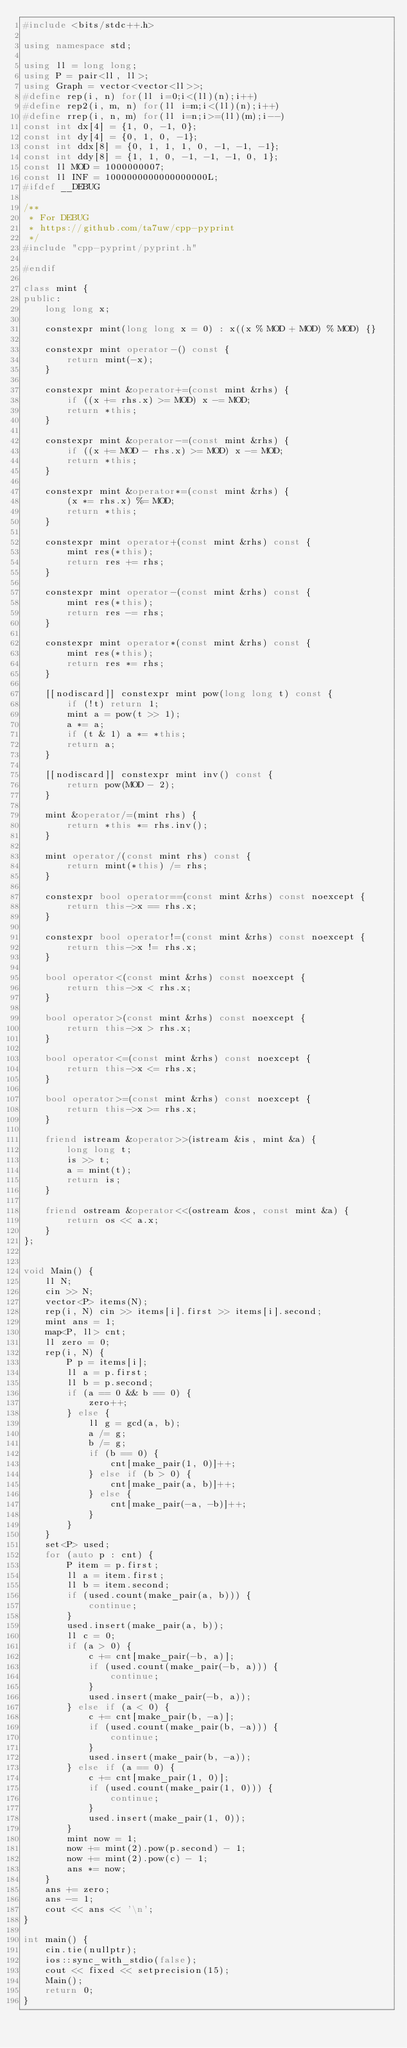<code> <loc_0><loc_0><loc_500><loc_500><_C++_>#include <bits/stdc++.h>

using namespace std;

using ll = long long;
using P = pair<ll, ll>;
using Graph = vector<vector<ll>>;
#define rep(i, n) for(ll i=0;i<(ll)(n);i++)
#define rep2(i, m, n) for(ll i=m;i<(ll)(n);i++)
#define rrep(i, n, m) for(ll i=n;i>=(ll)(m);i--)
const int dx[4] = {1, 0, -1, 0};
const int dy[4] = {0, 1, 0, -1};
const int ddx[8] = {0, 1, 1, 1, 0, -1, -1, -1};
const int ddy[8] = {1, 1, 0, -1, -1, -1, 0, 1};
const ll MOD = 1000000007;
const ll INF = 1000000000000000000L;
#ifdef __DEBUG

/**
 * For DEBUG
 * https://github.com/ta7uw/cpp-pyprint
 */
#include "cpp-pyprint/pyprint.h"

#endif

class mint {
public:
    long long x;

    constexpr mint(long long x = 0) : x((x % MOD + MOD) % MOD) {}

    constexpr mint operator-() const {
        return mint(-x);
    }

    constexpr mint &operator+=(const mint &rhs) {
        if ((x += rhs.x) >= MOD) x -= MOD;
        return *this;
    }

    constexpr mint &operator-=(const mint &rhs) {
        if ((x += MOD - rhs.x) >= MOD) x -= MOD;
        return *this;
    }

    constexpr mint &operator*=(const mint &rhs) {
        (x *= rhs.x) %= MOD;
        return *this;
    }

    constexpr mint operator+(const mint &rhs) const {
        mint res(*this);
        return res += rhs;
    }

    constexpr mint operator-(const mint &rhs) const {
        mint res(*this);
        return res -= rhs;
    }

    constexpr mint operator*(const mint &rhs) const {
        mint res(*this);
        return res *= rhs;
    }

    [[nodiscard]] constexpr mint pow(long long t) const {
        if (!t) return 1;
        mint a = pow(t >> 1);
        a *= a;
        if (t & 1) a *= *this;
        return a;
    }

    [[nodiscard]] constexpr mint inv() const {
        return pow(MOD - 2);
    }

    mint &operator/=(mint rhs) {
        return *this *= rhs.inv();
    }

    mint operator/(const mint rhs) const {
        return mint(*this) /= rhs;
    }

    constexpr bool operator==(const mint &rhs) const noexcept {
        return this->x == rhs.x;
    }

    constexpr bool operator!=(const mint &rhs) const noexcept {
        return this->x != rhs.x;
    }

    bool operator<(const mint &rhs) const noexcept {
        return this->x < rhs.x;
    }

    bool operator>(const mint &rhs) const noexcept {
        return this->x > rhs.x;
    }

    bool operator<=(const mint &rhs) const noexcept {
        return this->x <= rhs.x;
    }

    bool operator>=(const mint &rhs) const noexcept {
        return this->x >= rhs.x;
    }

    friend istream &operator>>(istream &is, mint &a) {
        long long t;
        is >> t;
        a = mint(t);
        return is;
    }

    friend ostream &operator<<(ostream &os, const mint &a) {
        return os << a.x;
    }
};


void Main() {
    ll N;
    cin >> N;
    vector<P> items(N);
    rep(i, N) cin >> items[i].first >> items[i].second;
    mint ans = 1;
    map<P, ll> cnt;
    ll zero = 0;
    rep(i, N) {
        P p = items[i];
        ll a = p.first;
        ll b = p.second;
        if (a == 0 && b == 0) {
            zero++;
        } else {
            ll g = gcd(a, b);
            a /= g;
            b /= g;
            if (b == 0) {
                cnt[make_pair(1, 0)]++;
            } else if (b > 0) {
                cnt[make_pair(a, b)]++;
            } else {
                cnt[make_pair(-a, -b)]++;
            }
        }
    }
    set<P> used;
    for (auto p : cnt) {
        P item = p.first;
        ll a = item.first;
        ll b = item.second;
        if (used.count(make_pair(a, b))) {
            continue;
        }
        used.insert(make_pair(a, b));
        ll c = 0;
        if (a > 0) {
            c += cnt[make_pair(-b, a)];
            if (used.count(make_pair(-b, a))) {
                continue;
            }
            used.insert(make_pair(-b, a));
        } else if (a < 0) {
            c += cnt[make_pair(b, -a)];
            if (used.count(make_pair(b, -a))) {
                continue;
            }
            used.insert(make_pair(b, -a));
        } else if (a == 0) {
            c += cnt[make_pair(1, 0)];
            if (used.count(make_pair(1, 0))) {
                continue;
            }
            used.insert(make_pair(1, 0));
        }
        mint now = 1;
        now += mint(2).pow(p.second) - 1;
        now += mint(2).pow(c) - 1;
        ans *= now;
    }
    ans += zero;
    ans -= 1;
    cout << ans << '\n';
}

int main() {
    cin.tie(nullptr);
    ios::sync_with_stdio(false);
    cout << fixed << setprecision(15);
    Main();
    return 0;
}
</code> 